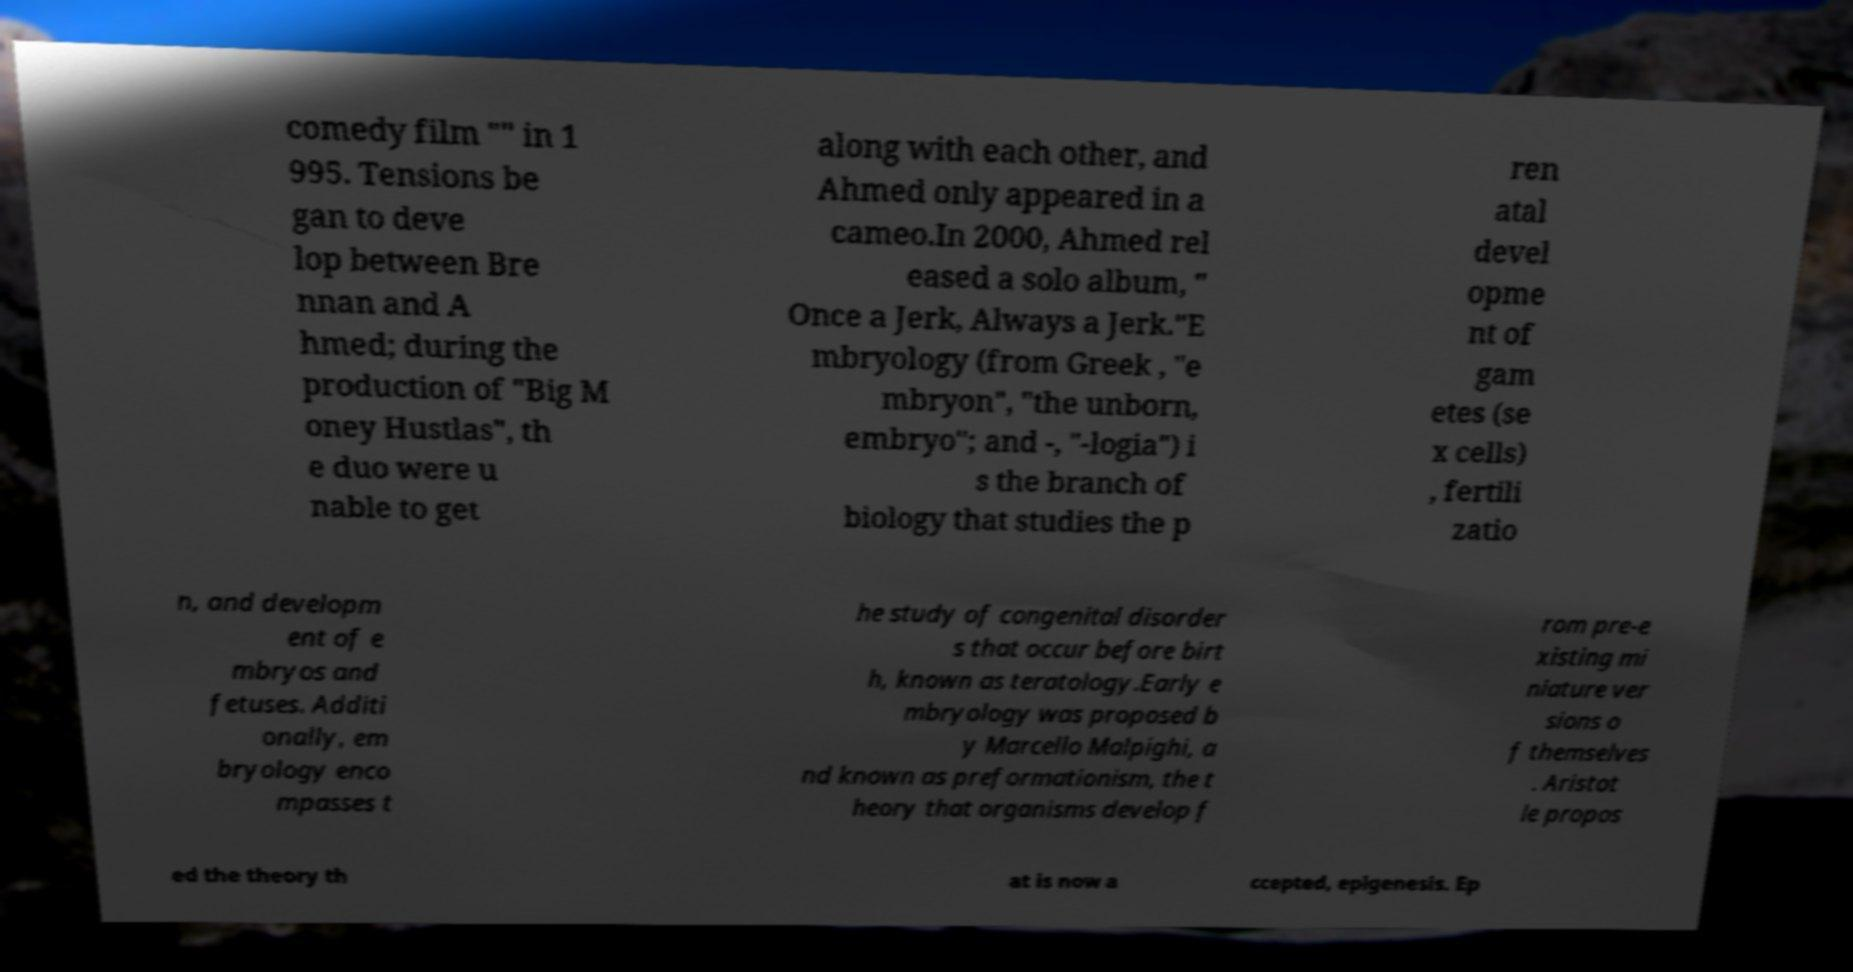What messages or text are displayed in this image? I need them in a readable, typed format. comedy film "" in 1 995. Tensions be gan to deve lop between Bre nnan and A hmed; during the production of "Big M oney Hustlas", th e duo were u nable to get along with each other, and Ahmed only appeared in a cameo.In 2000, Ahmed rel eased a solo album, " Once a Jerk, Always a Jerk."E mbryology (from Greek , "e mbryon", "the unborn, embryo"; and -, "-logia") i s the branch of biology that studies the p ren atal devel opme nt of gam etes (se x cells) , fertili zatio n, and developm ent of e mbryos and fetuses. Additi onally, em bryology enco mpasses t he study of congenital disorder s that occur before birt h, known as teratology.Early e mbryology was proposed b y Marcello Malpighi, a nd known as preformationism, the t heory that organisms develop f rom pre-e xisting mi niature ver sions o f themselves . Aristot le propos ed the theory th at is now a ccepted, epigenesis. Ep 